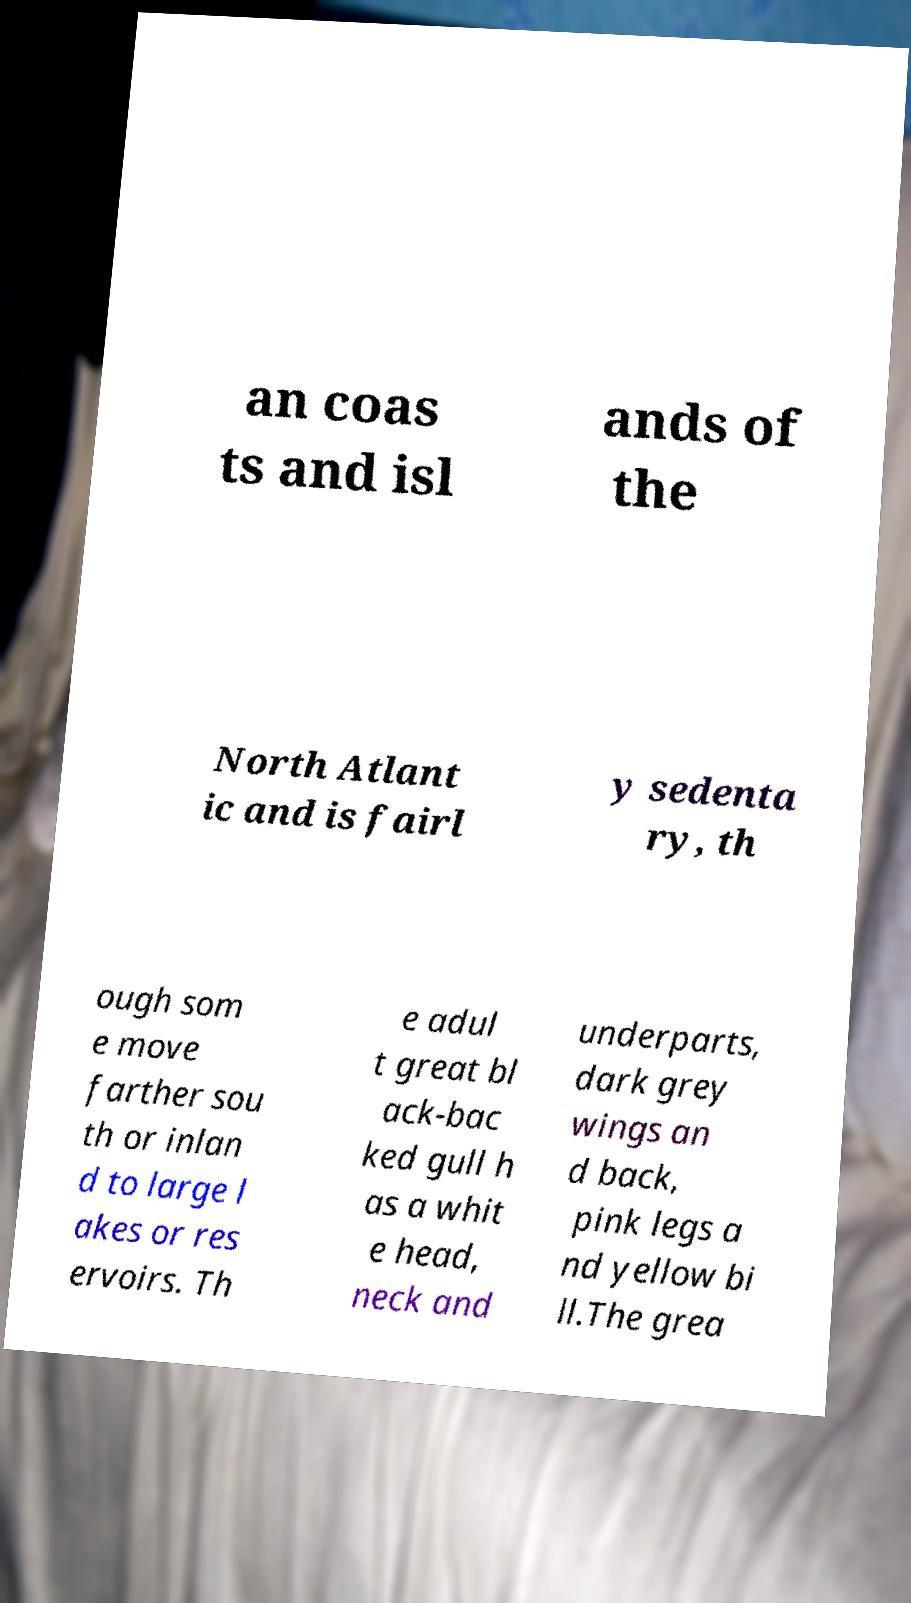I need the written content from this picture converted into text. Can you do that? an coas ts and isl ands of the North Atlant ic and is fairl y sedenta ry, th ough som e move farther sou th or inlan d to large l akes or res ervoirs. Th e adul t great bl ack-bac ked gull h as a whit e head, neck and underparts, dark grey wings an d back, pink legs a nd yellow bi ll.The grea 